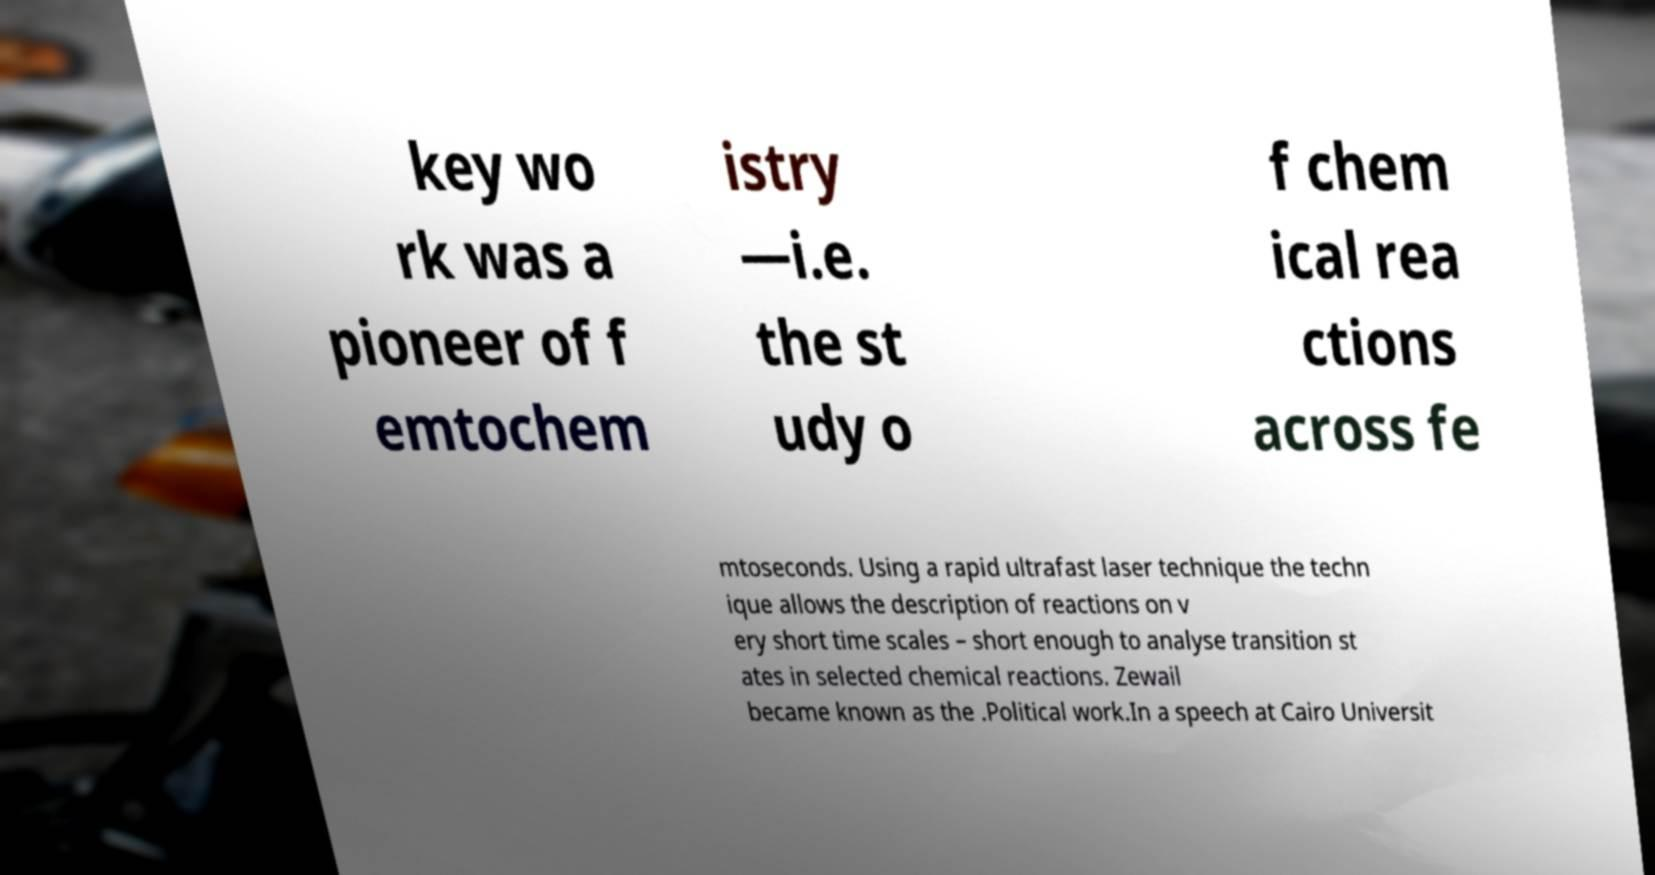Can you read and provide the text displayed in the image?This photo seems to have some interesting text. Can you extract and type it out for me? key wo rk was a pioneer of f emtochem istry —i.e. the st udy o f chem ical rea ctions across fe mtoseconds. Using a rapid ultrafast laser technique the techn ique allows the description of reactions on v ery short time scales – short enough to analyse transition st ates in selected chemical reactions. Zewail became known as the .Political work.In a speech at Cairo Universit 